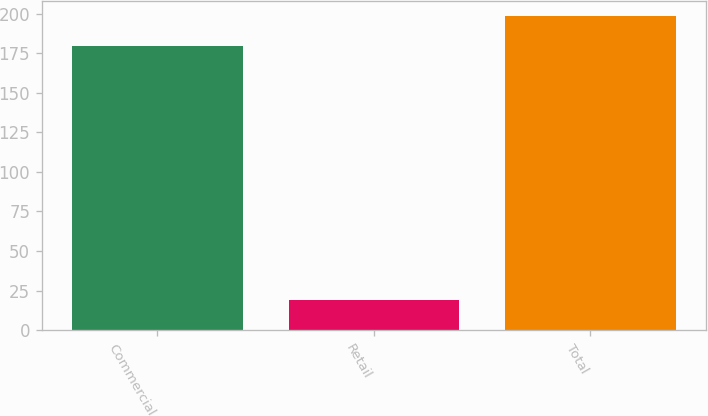<chart> <loc_0><loc_0><loc_500><loc_500><bar_chart><fcel>Commercial<fcel>Retail<fcel>Total<nl><fcel>179.4<fcel>18.9<fcel>198.3<nl></chart> 